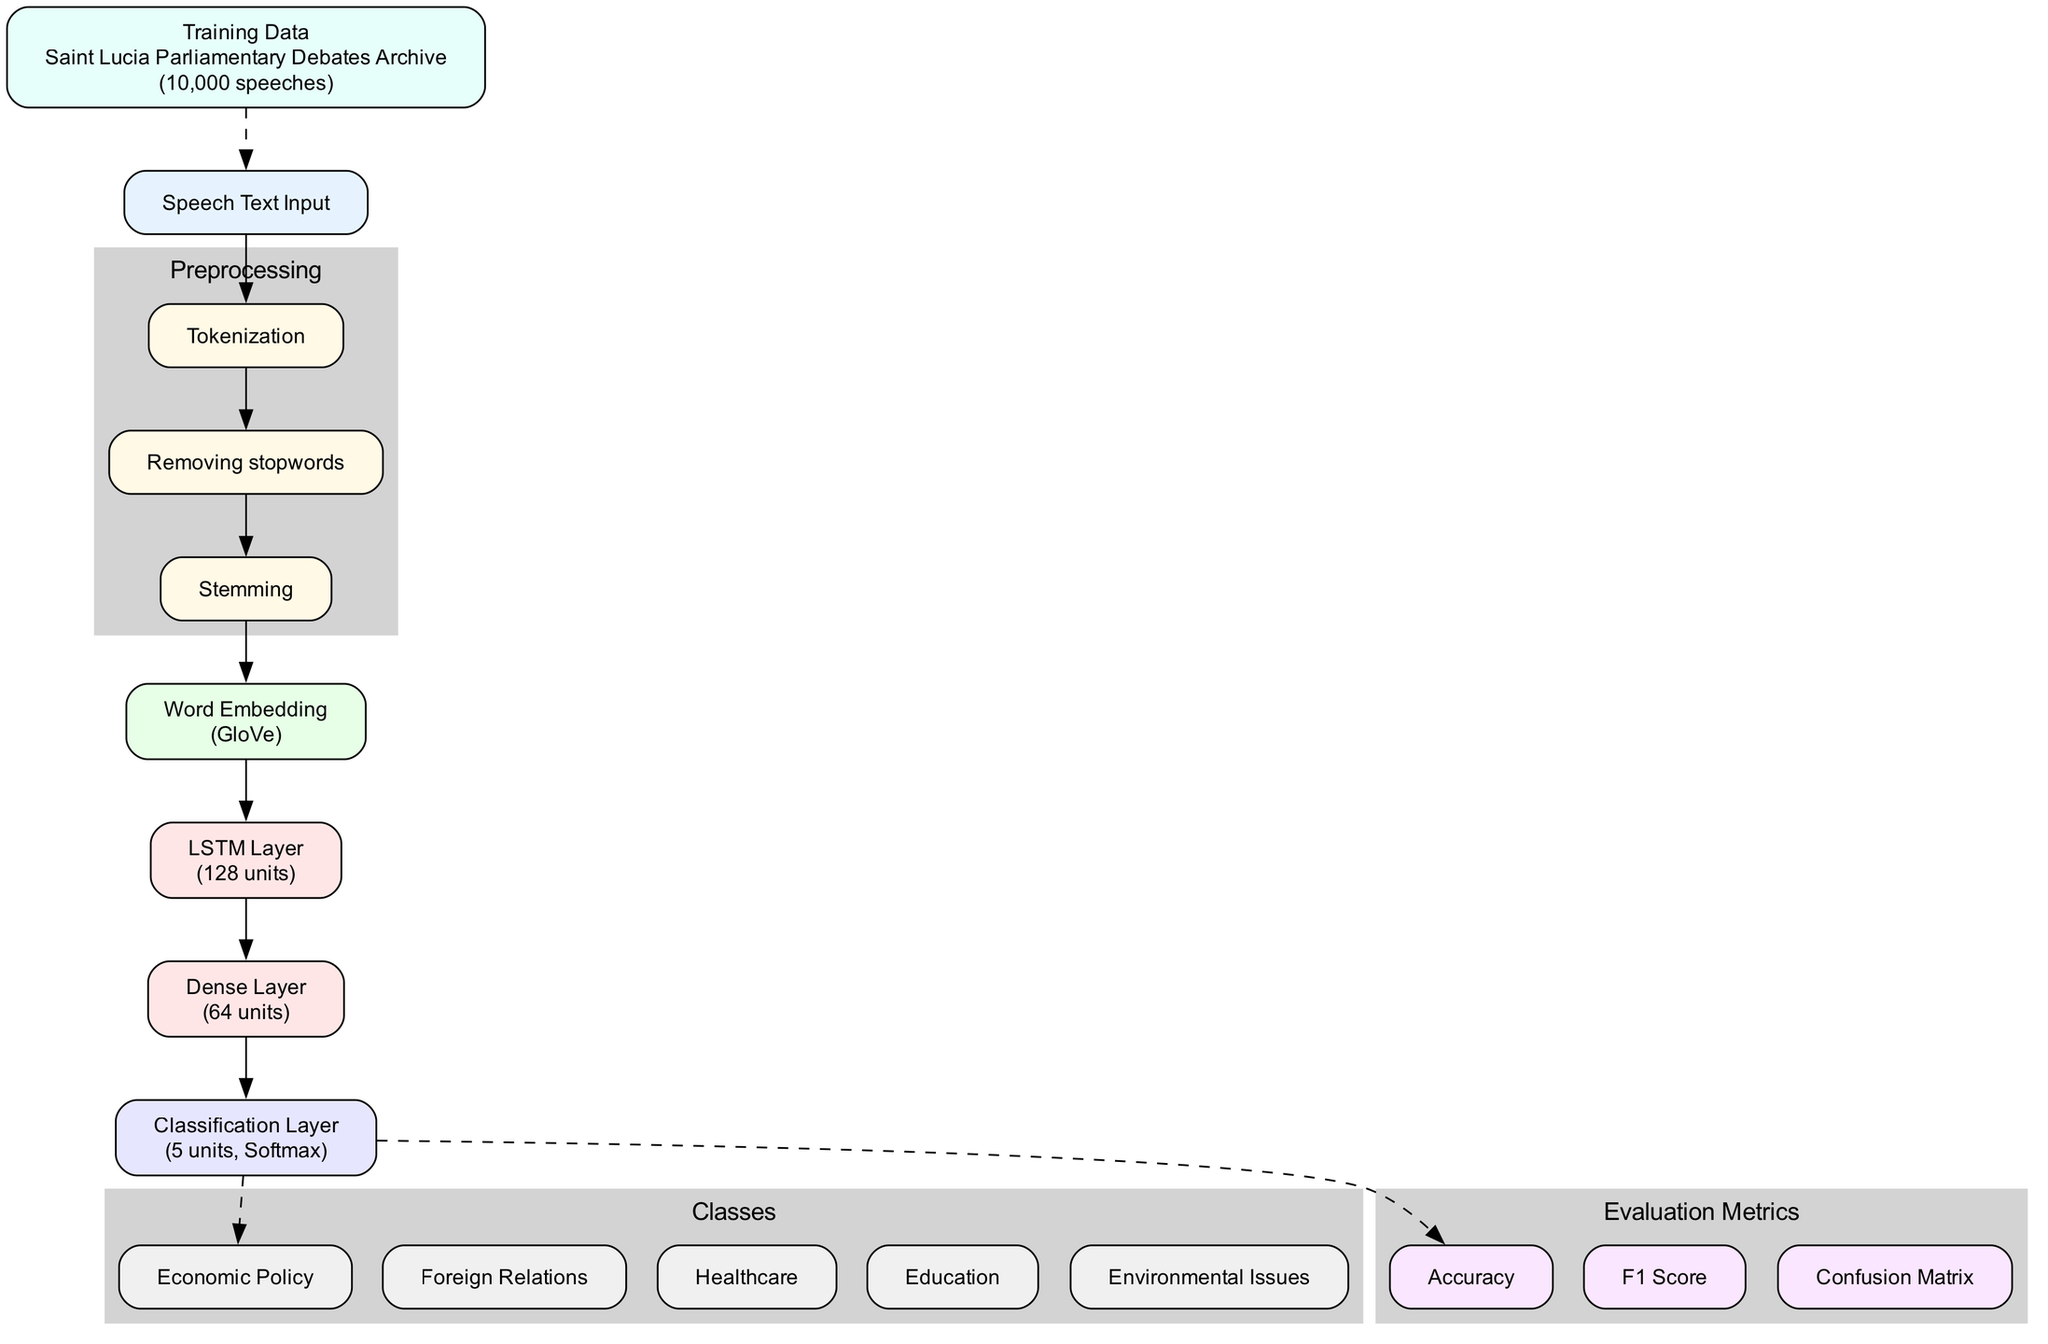What is the name of the input layer? The input layer is labeled "Speech Text Input" in the diagram.
Answer: Speech Text Input How many hidden layers are in the diagram? There are two hidden layers in the diagram, which are the LSTM Layer and the Dense Layer.
Answer: 2 What is the activation function used in the output layer? The output layer specifies the use of the "Softmax" activation function.
Answer: Softmax What type of word embedding is used in the model? The diagram indicates that the model uses "GloVe" for word embedding.
Answer: GloVe What are the evaluation metrics used in this architecture? The diagram lists three evaluation metrics: Accuracy, F1 Score, and Confusion Matrix. This requires analyzing the evaluation metrics cluster to get the answer.
Answer: Accuracy, F1 Score, Confusion Matrix In which subgraph are the preprocessing steps located? The preprocessing steps are within the subgraph labeled "Preprocessing". This is identified by looking at the labeled cluster in the diagram.
Answer: Preprocessing How many classes are identified in this classification model? The diagram lists five different classes for the output layer, indicating the categories the model will classify.
Answer: 5 Which layer does the training data connect to? The training data node connects to the input layer, as shown by the dashed edge leading from the training data to the Speech Text Input node.
Answer: Speech Text Input What is the number of units in the Dense Layer? The Dense Layer specifies having 64 units, as noted next to its name in the diagram.
Answer: 64 What is the source of the training data? The training data's source is indicated as "Saint Lucia Parliamentary Debates Archive" in the diagram.
Answer: Saint Lucia Parliamentary Debates Archive 